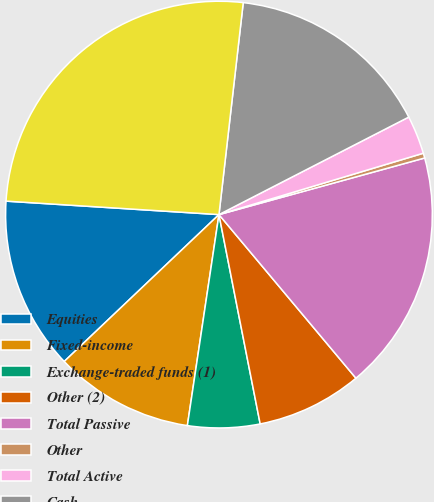Convert chart to OTSL. <chart><loc_0><loc_0><loc_500><loc_500><pie_chart><fcel>Equities<fcel>Fixed-income<fcel>Exchange-traded funds (1)<fcel>Other (2)<fcel>Total Passive<fcel>Other<fcel>Total Active<fcel>Cash<fcel>Total<nl><fcel>13.09%<fcel>10.55%<fcel>5.46%<fcel>8.0%<fcel>18.18%<fcel>0.37%<fcel>2.91%<fcel>15.63%<fcel>25.81%<nl></chart> 